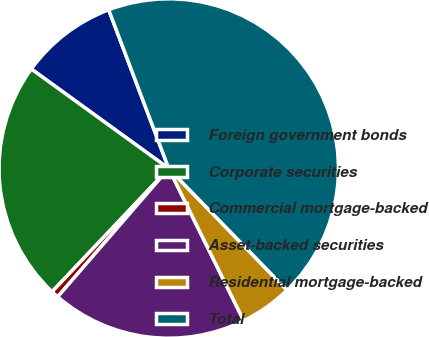Convert chart. <chart><loc_0><loc_0><loc_500><loc_500><pie_chart><fcel>Foreign government bonds<fcel>Corporate securities<fcel>Commercial mortgage-backed<fcel>Asset-backed securities<fcel>Residential mortgage-backed<fcel>Total<nl><fcel>9.27%<fcel>22.91%<fcel>0.71%<fcel>18.64%<fcel>4.99%<fcel>43.48%<nl></chart> 